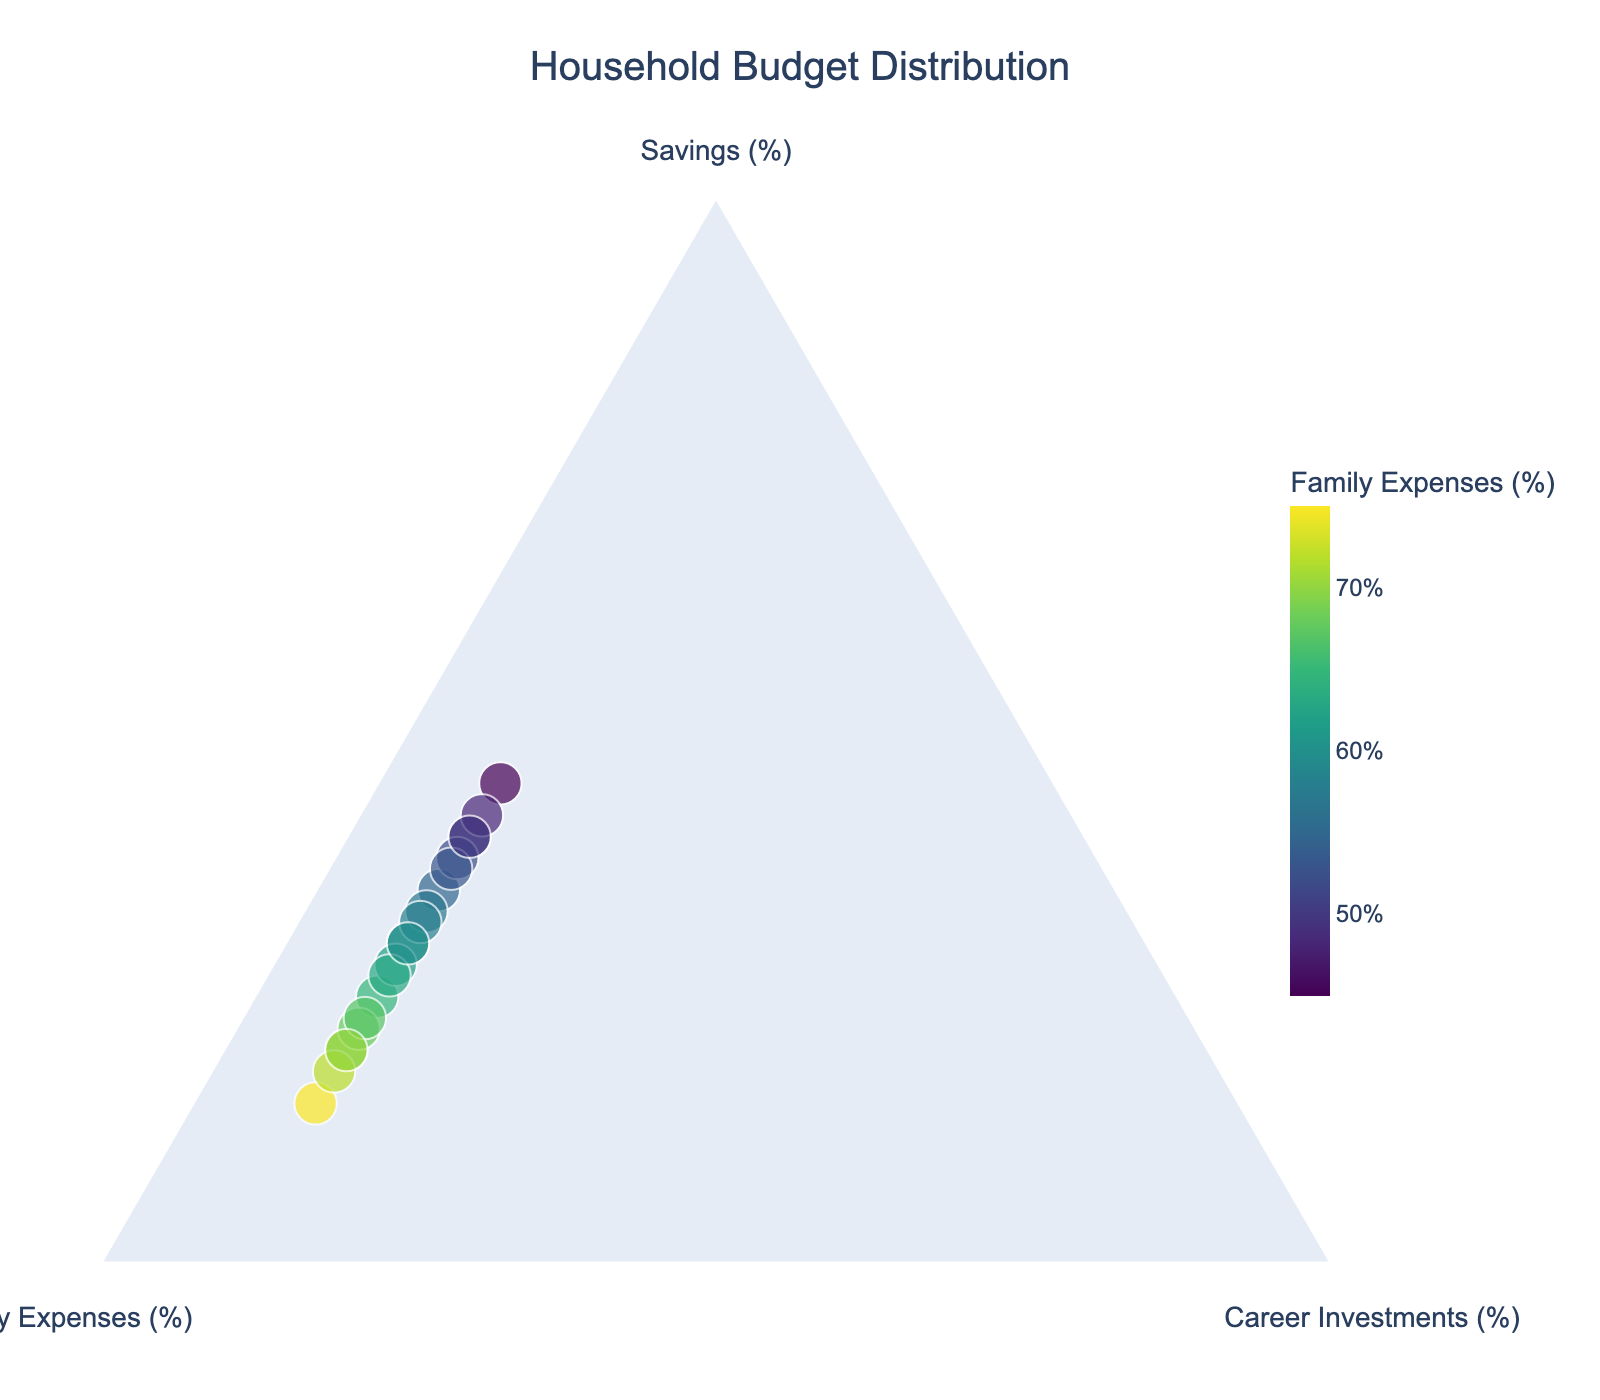What is the title of the plot? The title is displayed at the top of the figure, indicating the main subject of the visualization.
Answer: Household Budget Distribution How many data points are there in the plot? By counting the number of individual markers on the plot, we determine the total number of data points. Each marker represents a data point.
Answer: 20 Which axis represents family expenses? In a ternary plot, there are three axes. The axis labeled as "Family Expenses (%)" represents family expenses.
Answer: The axis labeled "Family Expenses (%)" What is the color scale used for in the plot? The color scale helps to visually distinguish different data points based on family expenses percentage. The legend indicates how colors correspond to family expenses percentages.
Answer: Family Expenses (%) Which data point has the highest savings percentage? Check the positions of each data point along the "Savings" axis. The point(s) nearest to 100% savings will represent the highest savings percentage.
Answer: 45% Considering the data points, what is the range of family expenses percentages? The color scale and data point positions along the family expenses axis indicate the range of family expenses percentages.
Answer: 45% to 75% What is the typical range for career investments percentage in this data? The positions of all data points along the "Career Investments" axis reveal the range of values. For this dataset, career investments percentage appears to be consistent.
Answer: 10% Which two data points differ the most in terms of savings and family expenses percentages? Compare the positions of each data point along the Savings and Family Expenses axes. Two points with the greatest difference in position along these axes will show the most substantial difference.
Answer: 15% savings and 75% family expenses vs. 45% savings and 45% family expenses What's the average savings percentage across all data points? Add up all the savings percentages and divide by the number of data points to find the mean savings percentage. The dataset includes 20 data points with varying percentages.
Answer: 30% How does the family expenses distribution compare to the savings distribution? Analyze the spread and central tendency of data points along the family expenses axis in relation to the savings axis. Note the concentration and spread of points.
Answer: Family expenses generally range higher and more narrowly than savings 